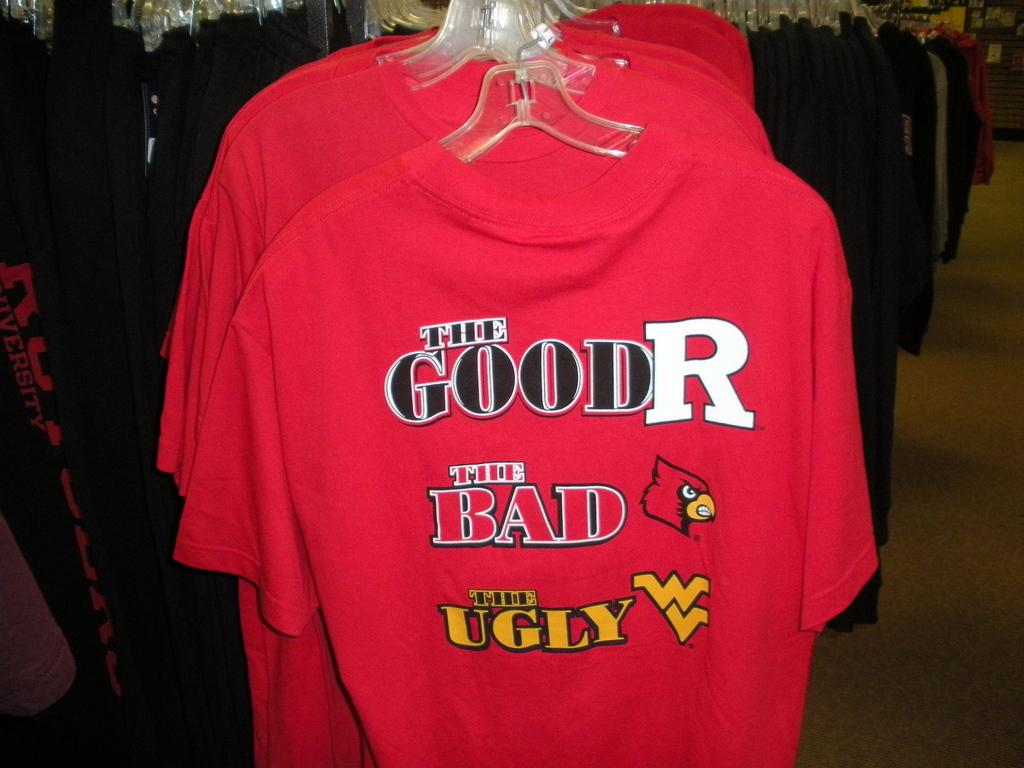What type of items can be seen in the image? There are clothes in the image. Can you describe one specific piece of clothing in the image? There is a red color t-shirt with text written on it in the image. How many houses can be seen in the image? There are no houses present in the image; it only features clothes. What type of floor is visible in the image? There is no floor visible in the image; it only features clothes. 